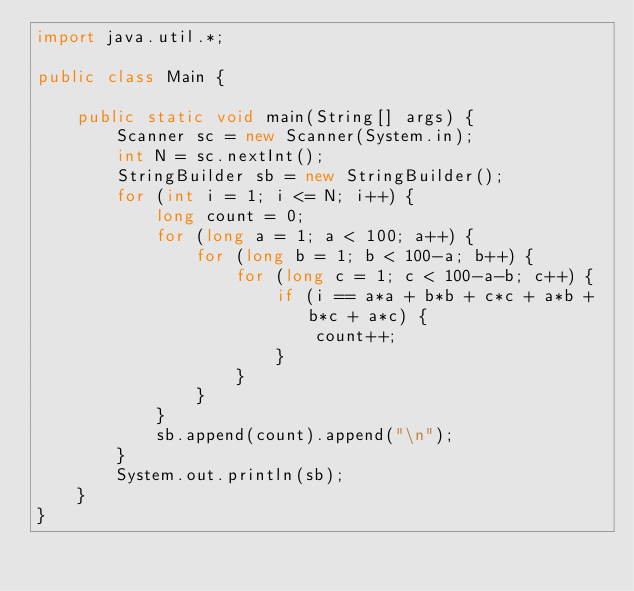<code> <loc_0><loc_0><loc_500><loc_500><_Java_>import java.util.*;

public class Main {
 
    public static void main(String[] args) {
        Scanner sc = new Scanner(System.in);
        int N = sc.nextInt();
        StringBuilder sb = new StringBuilder();
        for (int i = 1; i <= N; i++) {
            long count = 0;
            for (long a = 1; a < 100; a++) {
                for (long b = 1; b < 100-a; b++) {
                    for (long c = 1; c < 100-a-b; c++) {
                        if (i == a*a + b*b + c*c + a*b + b*c + a*c) {
                            count++;
                        }
                    }
                }
            }
            sb.append(count).append("\n");
        }
        System.out.println(sb);
    }
}</code> 